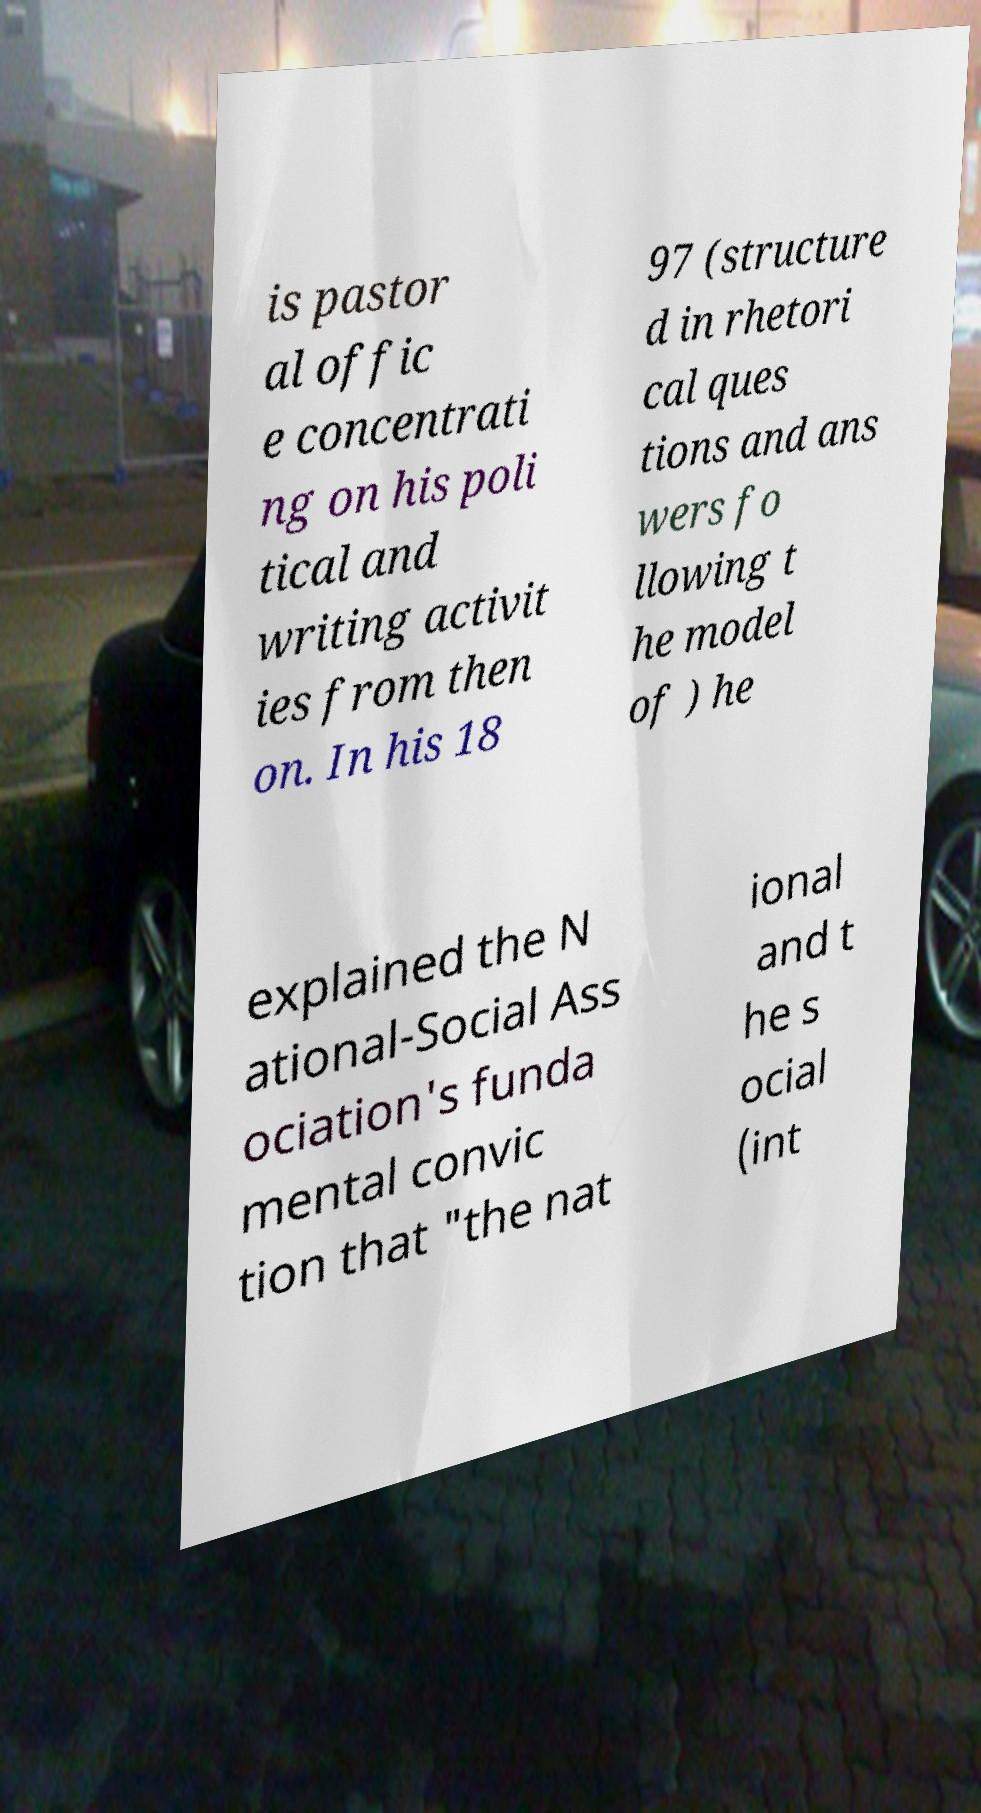What messages or text are displayed in this image? I need them in a readable, typed format. is pastor al offic e concentrati ng on his poli tical and writing activit ies from then on. In his 18 97 (structure d in rhetori cal ques tions and ans wers fo llowing t he model of ) he explained the N ational-Social Ass ociation's funda mental convic tion that "the nat ional and t he s ocial (int 